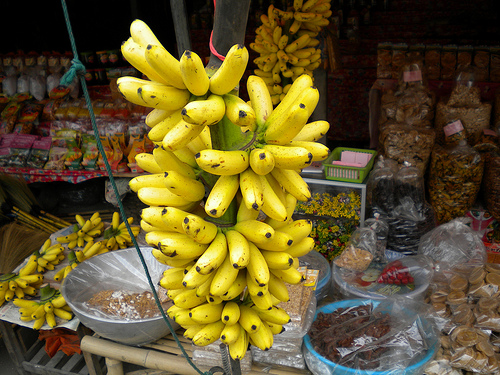Please provide the bounding box coordinate of the region this sentence describes: a ripe yellow banana. Identifying the outlined region of a ripe yellow banana yields the precise coordinates of [0.52, 0.33, 0.61, 0.41], capturing the essence of the market's fresh produce. 